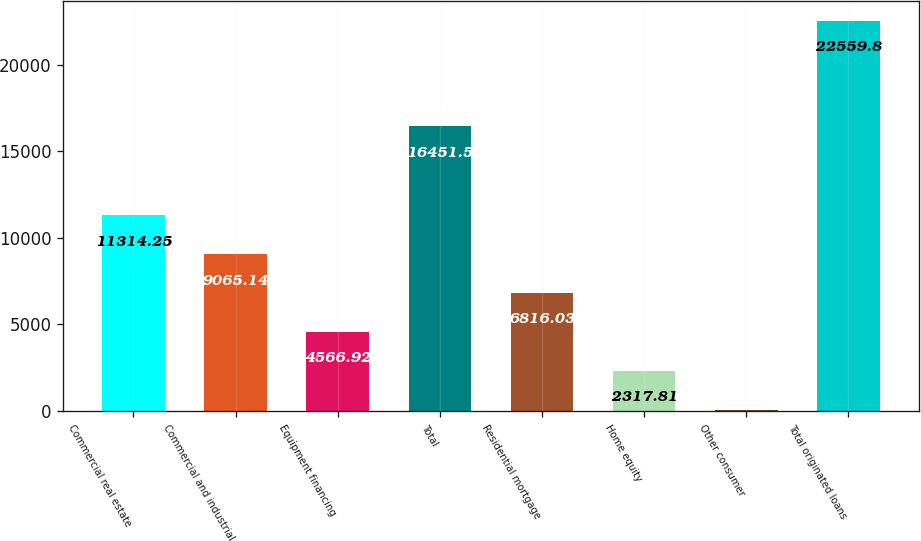<chart> <loc_0><loc_0><loc_500><loc_500><bar_chart><fcel>Commercial real estate<fcel>Commercial and industrial<fcel>Equipment financing<fcel>Total<fcel>Residential mortgage<fcel>Home equity<fcel>Other consumer<fcel>Total originated loans<nl><fcel>11314.2<fcel>9065.14<fcel>4566.92<fcel>16451.5<fcel>6816.03<fcel>2317.81<fcel>68.7<fcel>22559.8<nl></chart> 